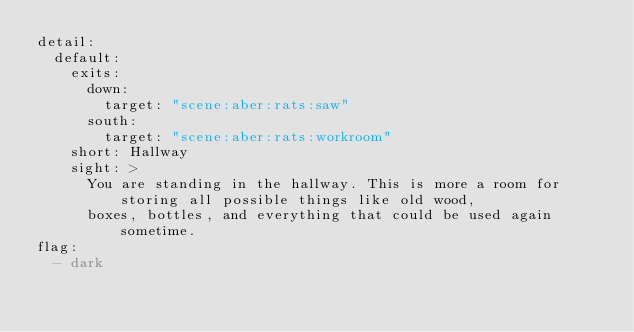<code> <loc_0><loc_0><loc_500><loc_500><_YAML_>detail:
  default:
    exits:
      down:
        target: "scene:aber:rats:saw"
      south:
        target: "scene:aber:rats:workroom"
    short: Hallway
    sight: >
      You are standing in the hallway. This is more a room for storing all possible things like old wood,
      boxes, bottles, and everything that could be used again sometime.
flag:
  - dark
</code> 